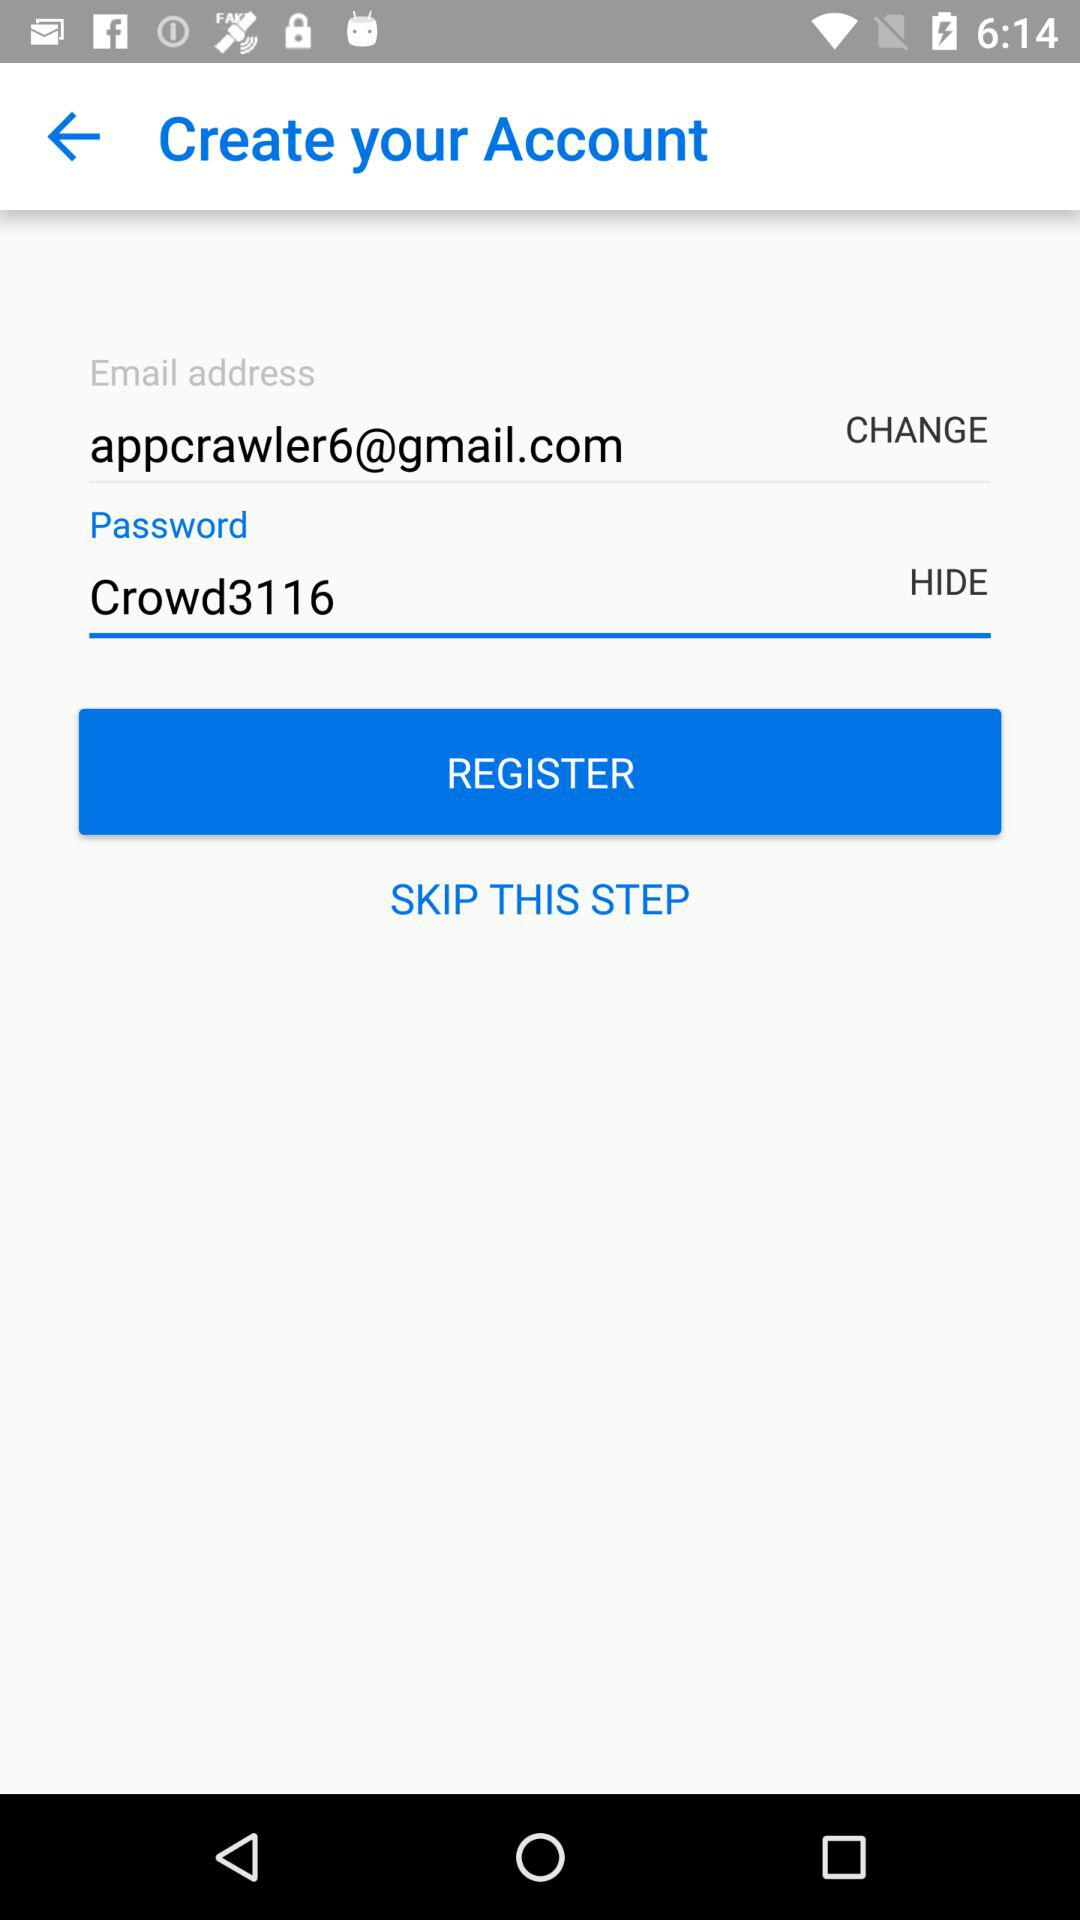What is the email address? The email address is appcrawler6@gmail.com. 